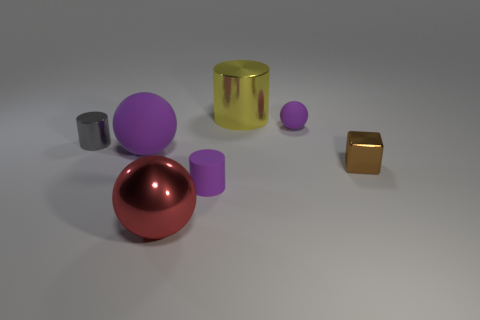There is a small metallic object that is to the right of the red thing; does it have the same shape as the tiny thing that is on the left side of the rubber cylinder?
Your response must be concise. No. There is a shiny cylinder that is behind the small purple rubber ball; is its size the same as the purple ball in front of the small matte ball?
Give a very brief answer. Yes. What number of things are either small brown metallic cubes or small metal cylinders?
Your response must be concise. 2. What material is the thing that is behind the sphere on the right side of the large yellow cylinder?
Your answer should be compact. Metal. What number of purple matte things have the same shape as the gray object?
Make the answer very short. 1. Is there a small rubber thing of the same color as the small rubber sphere?
Your response must be concise. Yes. How many objects are spheres that are right of the red thing or purple spheres to the right of the big yellow thing?
Give a very brief answer. 1. There is a metal object behind the gray object; is there a red ball in front of it?
Your answer should be compact. Yes. There is another rubber object that is the same size as the red thing; what shape is it?
Provide a short and direct response. Sphere. What number of things are either tiny objects that are left of the big yellow metal thing or small purple balls?
Provide a short and direct response. 3. 